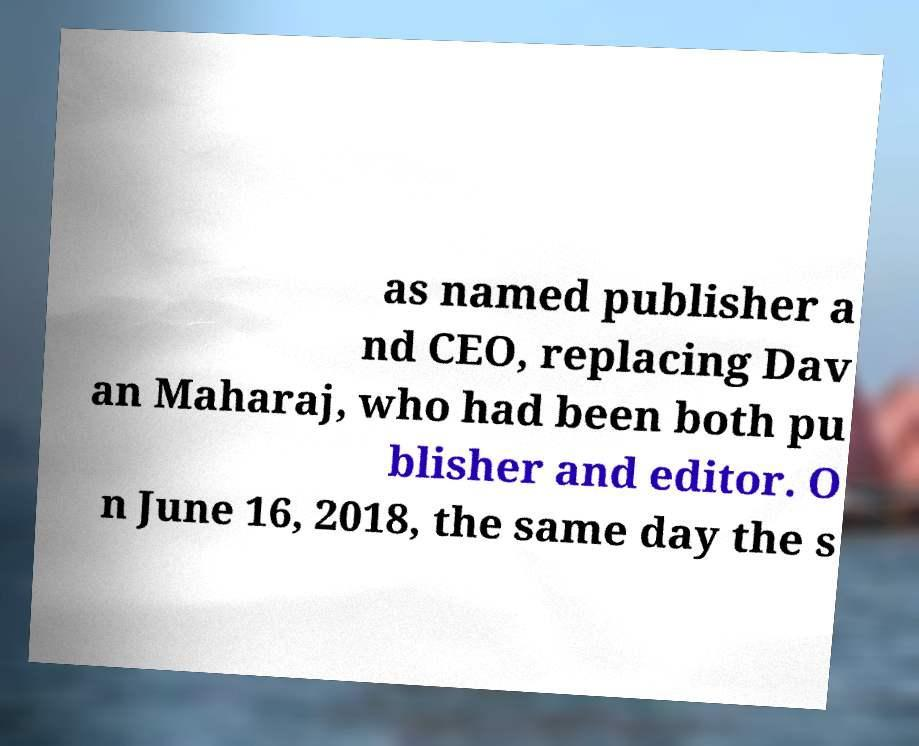Can you read and provide the text displayed in the image?This photo seems to have some interesting text. Can you extract and type it out for me? as named publisher a nd CEO, replacing Dav an Maharaj, who had been both pu blisher and editor. O n June 16, 2018, the same day the s 